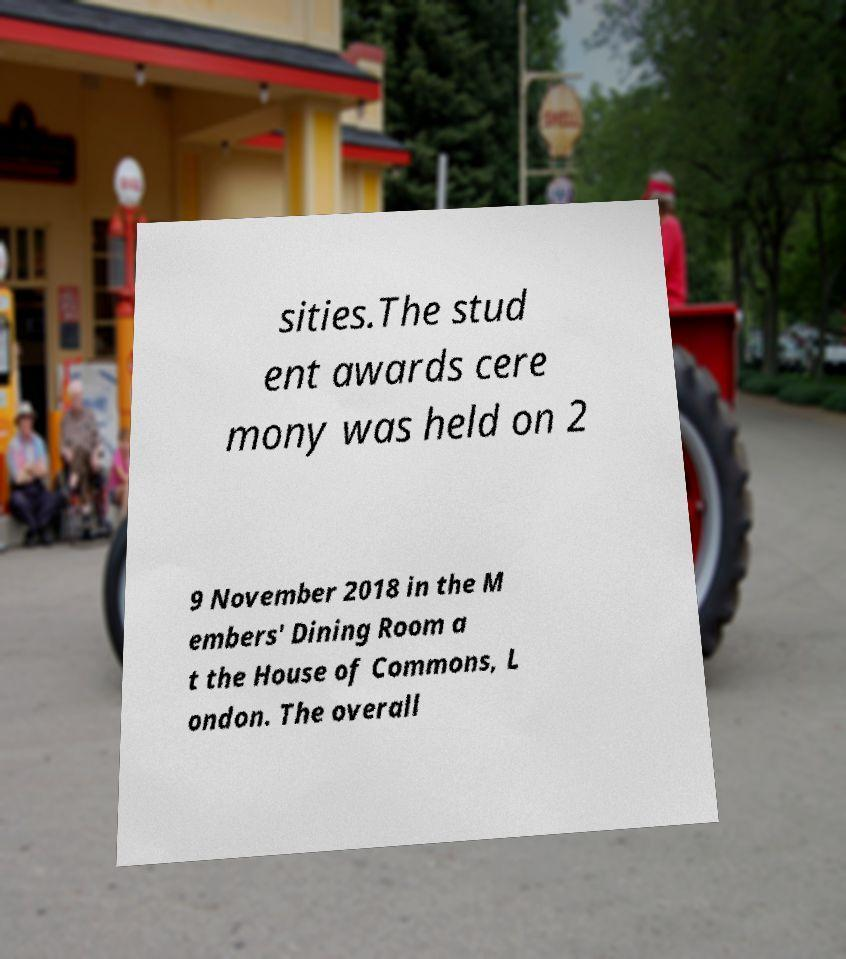Please read and relay the text visible in this image. What does it say? sities.The stud ent awards cere mony was held on 2 9 November 2018 in the M embers' Dining Room a t the House of Commons, L ondon. The overall 